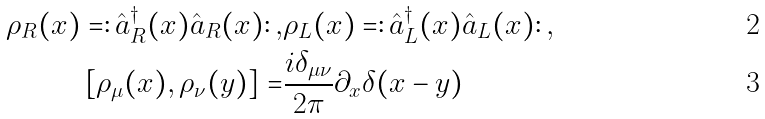<formula> <loc_0><loc_0><loc_500><loc_500>\rho _ { R } ( x ) = \colon \hat { a } ^ { \dagger } _ { R } ( x ) \hat { a } _ { R } ( x ) \colon , & \rho _ { L } ( x ) = \colon \hat { a } ^ { \dagger } _ { L } ( x ) \hat { a } _ { L } ( x ) \colon , \\ [ \rho _ { \mu } ( x ) , \rho _ { \nu } ( y ) ] = & \frac { i \delta _ { \mu \nu } } { 2 \pi } \partial _ { x } \delta ( x - y )</formula> 